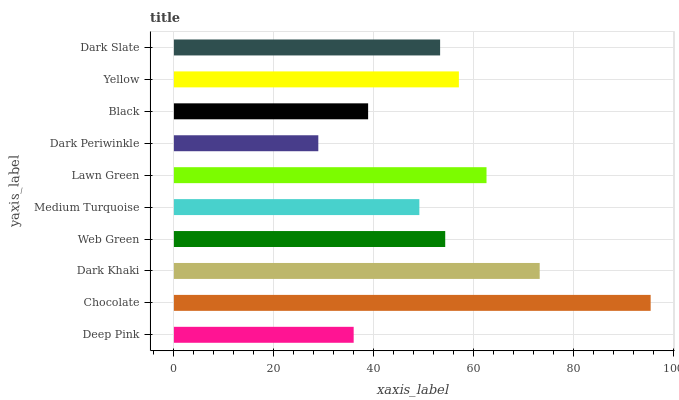Is Dark Periwinkle the minimum?
Answer yes or no. Yes. Is Chocolate the maximum?
Answer yes or no. Yes. Is Dark Khaki the minimum?
Answer yes or no. No. Is Dark Khaki the maximum?
Answer yes or no. No. Is Chocolate greater than Dark Khaki?
Answer yes or no. Yes. Is Dark Khaki less than Chocolate?
Answer yes or no. Yes. Is Dark Khaki greater than Chocolate?
Answer yes or no. No. Is Chocolate less than Dark Khaki?
Answer yes or no. No. Is Web Green the high median?
Answer yes or no. Yes. Is Dark Slate the low median?
Answer yes or no. Yes. Is Deep Pink the high median?
Answer yes or no. No. Is Lawn Green the low median?
Answer yes or no. No. 